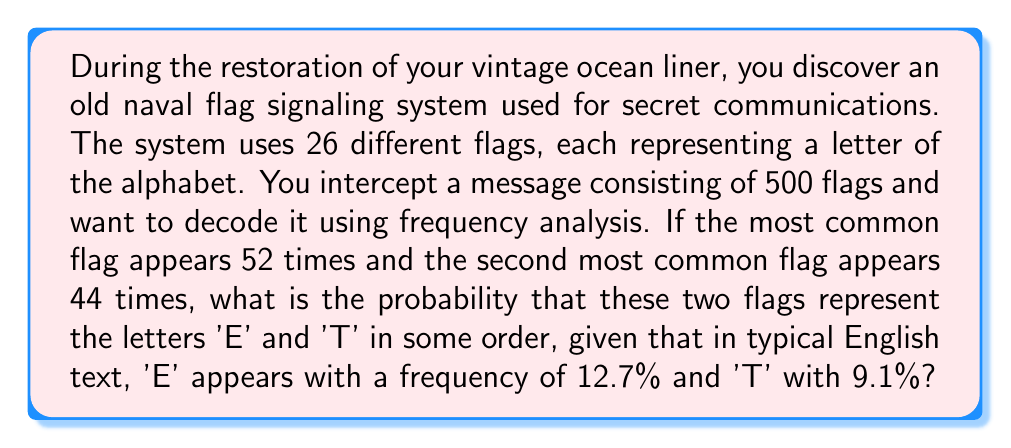Provide a solution to this math problem. Let's approach this step-by-step:

1) First, we need to calculate the observed frequencies of the two most common flags:
   Most common flag: $\frac{52}{500} = 0.104 = 10.4\%$
   Second most common flag: $\frac{44}{500} = 0.088 = 8.8\%$

2) Now, we need to compare these to the expected frequencies of 'E' and 'T':
   'E': 12.7%
   'T': 9.1%

3) We can see that the observed frequencies are close to, but not exactly the same as, the expected frequencies. This is normal due to natural variation in language and the limited sample size.

4) To calculate the probability, we need to consider two scenarios:
   a) The most common flag is 'E' and the second most common is 'T'
   b) The most common flag is 'T' and the second most common is 'E'

5) Let's calculate the probability of each scenario:
   a) P(most common is E AND second most common is T)
      $= P(10.4\% | E) \times P(8.8\% | T)$
   b) P(most common is T AND second most common is E)
      $= P(10.4\% | T) \times P(8.8\% | E)$

6) To calculate these probabilities, we can use a normal approximation. We'll assume a standard deviation of 1% for each letter's frequency.

7) For scenario a:
   $P(10.4\% | E) = P(Z < \frac{10.4 - 12.7}{1}) = P(Z < -2.3) = 0.0107$
   $P(8.8\% | T) = P(Z < \frac{8.8 - 9.1}{1}) = P(Z < -0.3) = 0.3821$
   $P(a) = 0.0107 \times 0.3821 = 0.00409$

8) For scenario b:
   $P(10.4\% | T) = P(Z < \frac{10.4 - 9.1}{1}) = P(Z < 1.3) = 0.9032$
   $P(8.8\% | E) = P(Z < \frac{8.8 - 12.7}{1}) = P(Z < -3.9) = 0.00005$
   $P(b) = 0.9032 \times 0.00005 = 0.00005$

9) The total probability is the sum of these two scenarios:
   $P(total) = P(a) + P(b) = 0.00409 + 0.00005 = 0.00414$

10) Converting to a percentage: $0.00414 \times 100 = 0.414\%$
Answer: 0.414% 